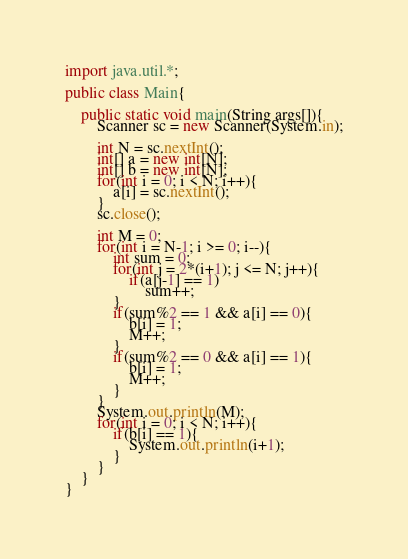<code> <loc_0><loc_0><loc_500><loc_500><_Java_>import java.util.*;

public class Main{
    
    public static void main(String args[]){
        Scanner sc = new Scanner(System.in);
        
        int N = sc.nextInt();
        int[] a = new int[N];
        int[] b = new int[N];
        for(int i = 0; i < N; i++){
            a[i] = sc.nextInt();
        }
        sc.close();
        
        int M = 0;
        for(int i = N-1; i >= 0; i--){
            int sum = 0;
            for(int j = 2*(i+1); j <= N; j++){
                if(a[j-1] == 1)
                    sum++;
            }
            if(sum%2 == 1 && a[i] == 0){
                b[i] = 1;
                M++;
            }
            if(sum%2 == 0 && a[i] == 1){
                b[i] = 1;
                M++;
            }
        }
        System.out.println(M);
        for(int i = 0; i < N; i++){
            if(b[i] == 1){
                System.out.println(i+1);
            }
        }
    }
}</code> 